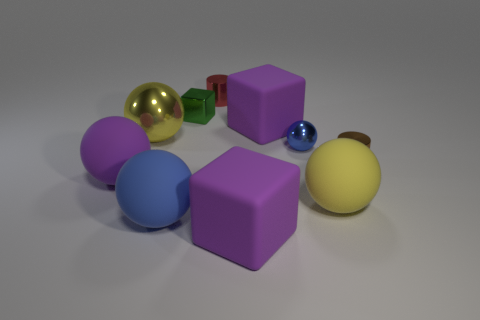What number of green metal cubes are in front of the metal cylinder that is in front of the large yellow ball that is behind the brown thing?
Your response must be concise. 0. What number of shiny things are large red cylinders or red things?
Provide a succinct answer. 1. There is a metallic cylinder that is to the right of the big block that is in front of the brown metallic object; how big is it?
Provide a succinct answer. Small. There is a metallic ball behind the small blue shiny sphere; is its color the same as the matte sphere right of the large blue matte sphere?
Provide a short and direct response. Yes. What is the color of the metal object that is both in front of the tiny green block and on the left side of the red cylinder?
Keep it short and to the point. Yellow. Does the red cylinder have the same material as the large purple ball?
Your answer should be very brief. No. What number of tiny objects are either yellow metal spheres or cyan cylinders?
Offer a very short reply. 0. There is a tiny sphere that is the same material as the brown cylinder; what is its color?
Your answer should be compact. Blue. There is a rubber cube that is in front of the blue rubber sphere; what is its color?
Provide a succinct answer. Purple. What number of big spheres are the same color as the big metallic thing?
Provide a short and direct response. 1. 